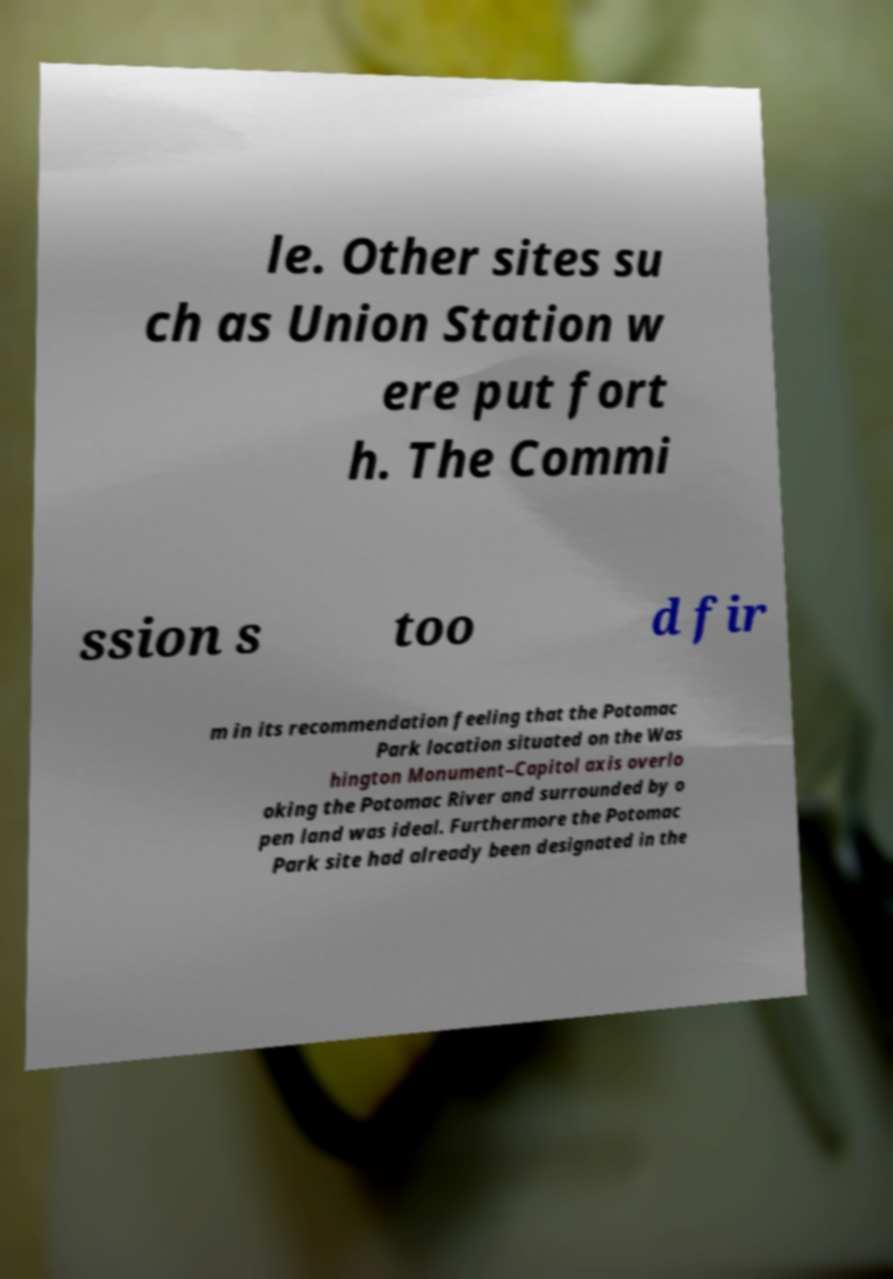I need the written content from this picture converted into text. Can you do that? le. Other sites su ch as Union Station w ere put fort h. The Commi ssion s too d fir m in its recommendation feeling that the Potomac Park location situated on the Was hington Monument–Capitol axis overlo oking the Potomac River and surrounded by o pen land was ideal. Furthermore the Potomac Park site had already been designated in the 